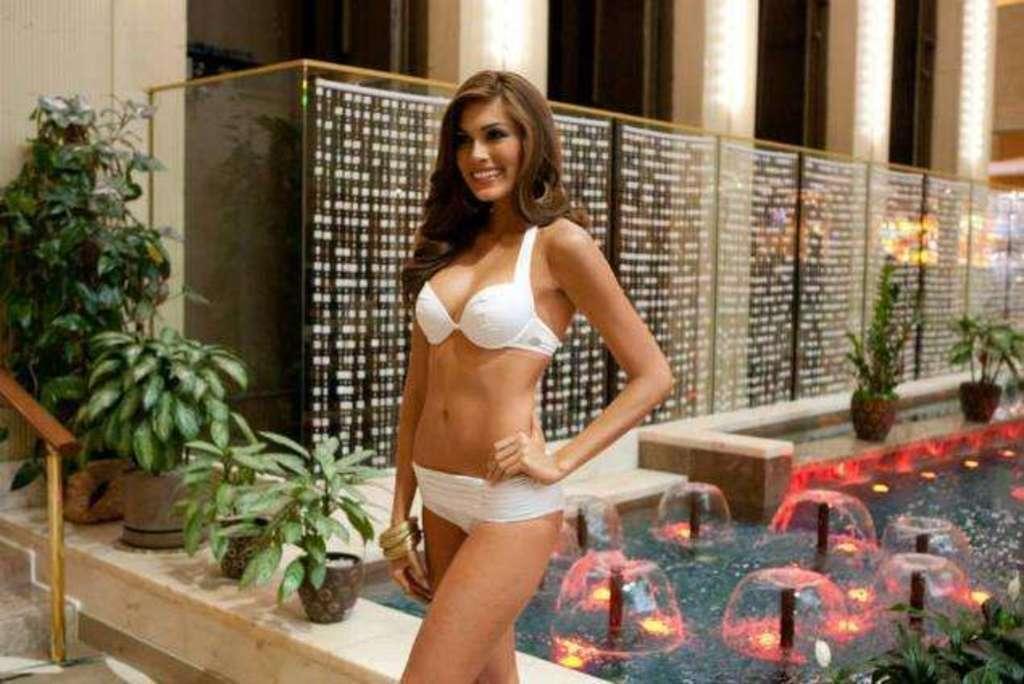In one or two sentences, can you explain what this image depicts? In this picture there is a woman who is wearing a white dress. She is standing near to the water. At the bottom i can see many small fountain. On the right i can see the glass partition near to the wall. In the top there are four windows. On the left i can see the plants and pots near to the wooden railing. In the bottom left corner there are stairs. 